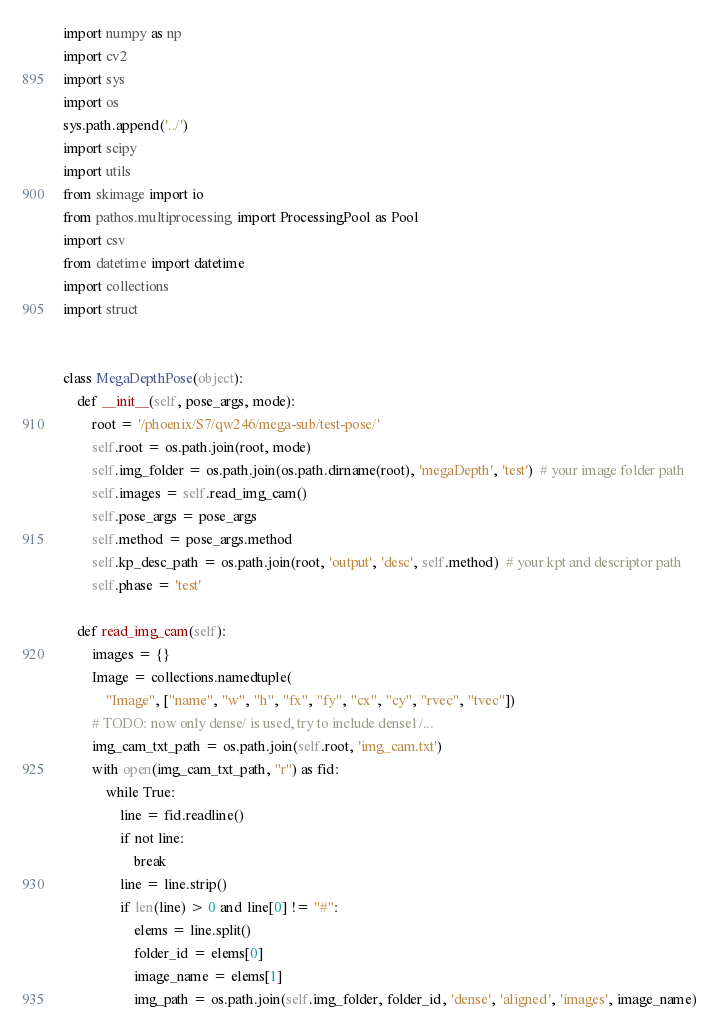<code> <loc_0><loc_0><loc_500><loc_500><_Python_>import numpy as np
import cv2
import sys
import os
sys.path.append('../')
import scipy
import utils
from skimage import io
from pathos.multiprocessing import ProcessingPool as Pool
import csv
from datetime import datetime
import collections
import struct


class MegaDepthPose(object):
    def __init__(self, pose_args, mode):
        root = '/phoenix/S7/qw246/mega-sub/test-pose/'
        self.root = os.path.join(root, mode)
        self.img_folder = os.path.join(os.path.dirname(root), 'megaDepth', 'test')  # your image folder path
        self.images = self.read_img_cam()
        self.pose_args = pose_args
        self.method = pose_args.method
        self.kp_desc_path = os.path.join(root, 'output', 'desc', self.method)  # your kpt and descriptor path
        self.phase = 'test'

    def read_img_cam(self):
        images = {}
        Image = collections.namedtuple(
            "Image", ["name", "w", "h", "fx", "fy", "cx", "cy", "rvec", "tvec"])
        # TODO: now only dense/ is used, try to include dense1/...
        img_cam_txt_path = os.path.join(self.root, 'img_cam.txt')
        with open(img_cam_txt_path, "r") as fid:
            while True:
                line = fid.readline()
                if not line:
                    break
                line = line.strip()
                if len(line) > 0 and line[0] != "#":
                    elems = line.split()
                    folder_id = elems[0]
                    image_name = elems[1]
                    img_path = os.path.join(self.img_folder, folder_id, 'dense', 'aligned', 'images', image_name)</code> 